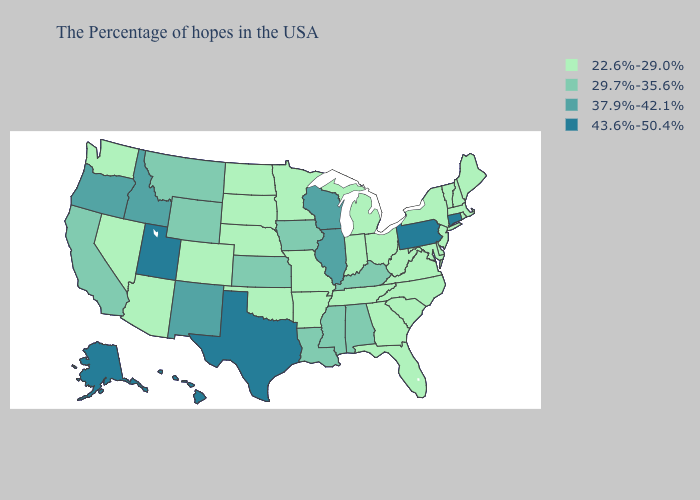Which states have the highest value in the USA?
Give a very brief answer. Connecticut, Pennsylvania, Texas, Utah, Alaska, Hawaii. Name the states that have a value in the range 43.6%-50.4%?
Write a very short answer. Connecticut, Pennsylvania, Texas, Utah, Alaska, Hawaii. Which states have the lowest value in the South?
Keep it brief. Delaware, Maryland, Virginia, North Carolina, South Carolina, West Virginia, Florida, Georgia, Tennessee, Arkansas, Oklahoma. What is the value of New York?
Quick response, please. 22.6%-29.0%. How many symbols are there in the legend?
Answer briefly. 4. Does Michigan have the lowest value in the MidWest?
Write a very short answer. Yes. What is the value of Iowa?
Keep it brief. 29.7%-35.6%. What is the value of Maryland?
Concise answer only. 22.6%-29.0%. What is the value of Virginia?
Write a very short answer. 22.6%-29.0%. Does the first symbol in the legend represent the smallest category?
Quick response, please. Yes. What is the value of North Carolina?
Quick response, please. 22.6%-29.0%. Does the map have missing data?
Quick response, please. No. Name the states that have a value in the range 29.7%-35.6%?
Give a very brief answer. Kentucky, Alabama, Mississippi, Louisiana, Iowa, Kansas, Wyoming, Montana, California. How many symbols are there in the legend?
Write a very short answer. 4. Does the first symbol in the legend represent the smallest category?
Answer briefly. Yes. 